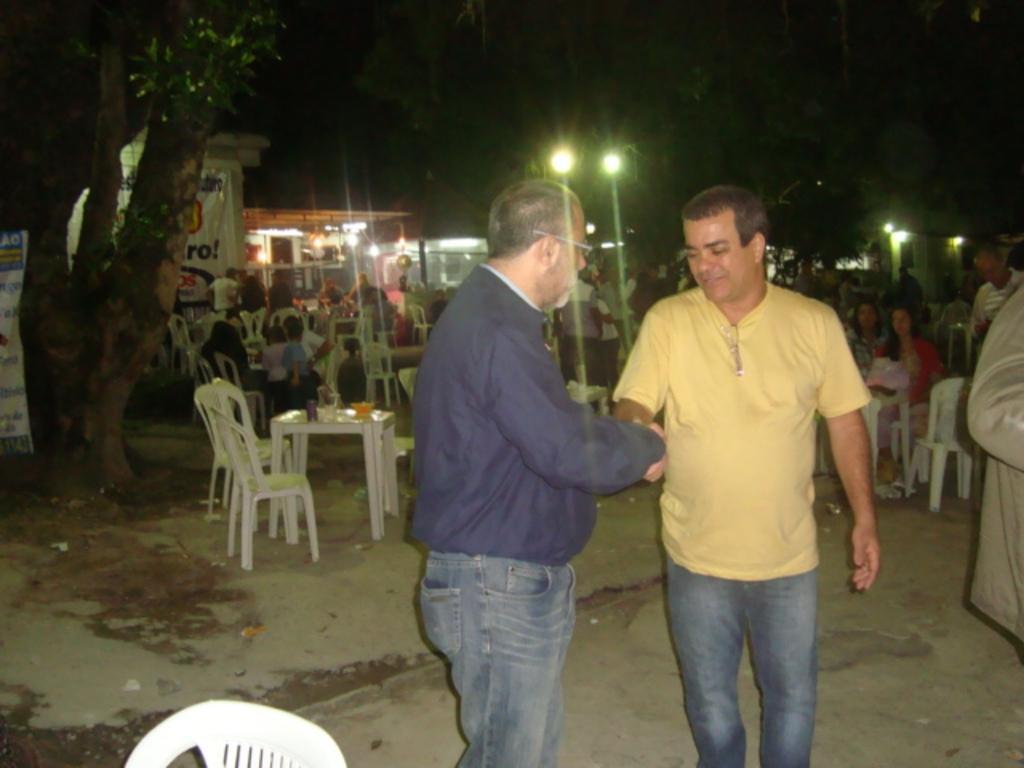In one or two sentences, can you explain what this image depicts? In this image I can see two men are standing and I can also see he is wearing a specs. In the background I can see number of chairs and number of people on it. I can also see few tables and trees. 